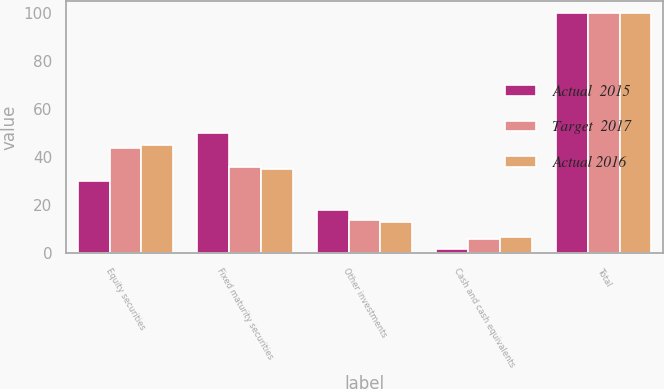<chart> <loc_0><loc_0><loc_500><loc_500><stacked_bar_chart><ecel><fcel>Equity securities<fcel>Fixed maturity securities<fcel>Other investments<fcel>Cash and cash equivalents<fcel>Total<nl><fcel>Actual  2015<fcel>30<fcel>50<fcel>18<fcel>2<fcel>100<nl><fcel>Target  2017<fcel>44<fcel>36<fcel>14<fcel>6<fcel>100<nl><fcel>Actual 2016<fcel>45<fcel>35<fcel>13<fcel>7<fcel>100<nl></chart> 